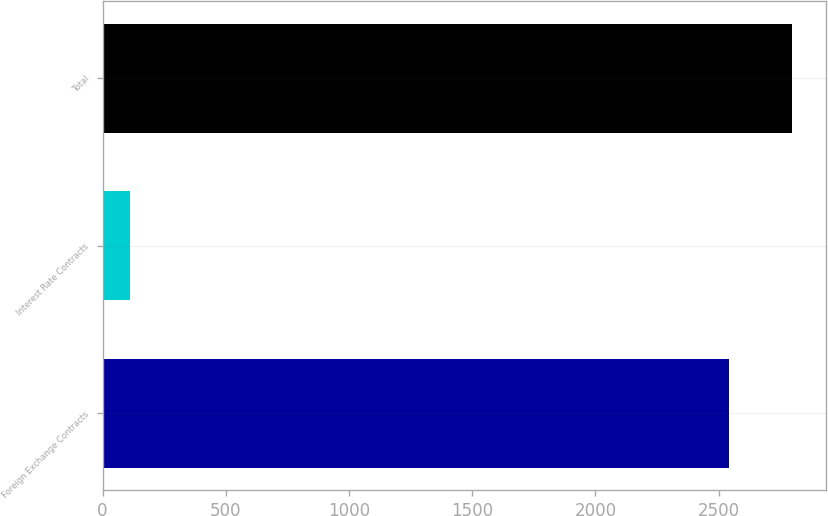Convert chart to OTSL. <chart><loc_0><loc_0><loc_500><loc_500><bar_chart><fcel>Foreign Exchange Contracts<fcel>Interest Rate Contracts<fcel>Total<nl><fcel>2541.8<fcel>111.1<fcel>2795.98<nl></chart> 